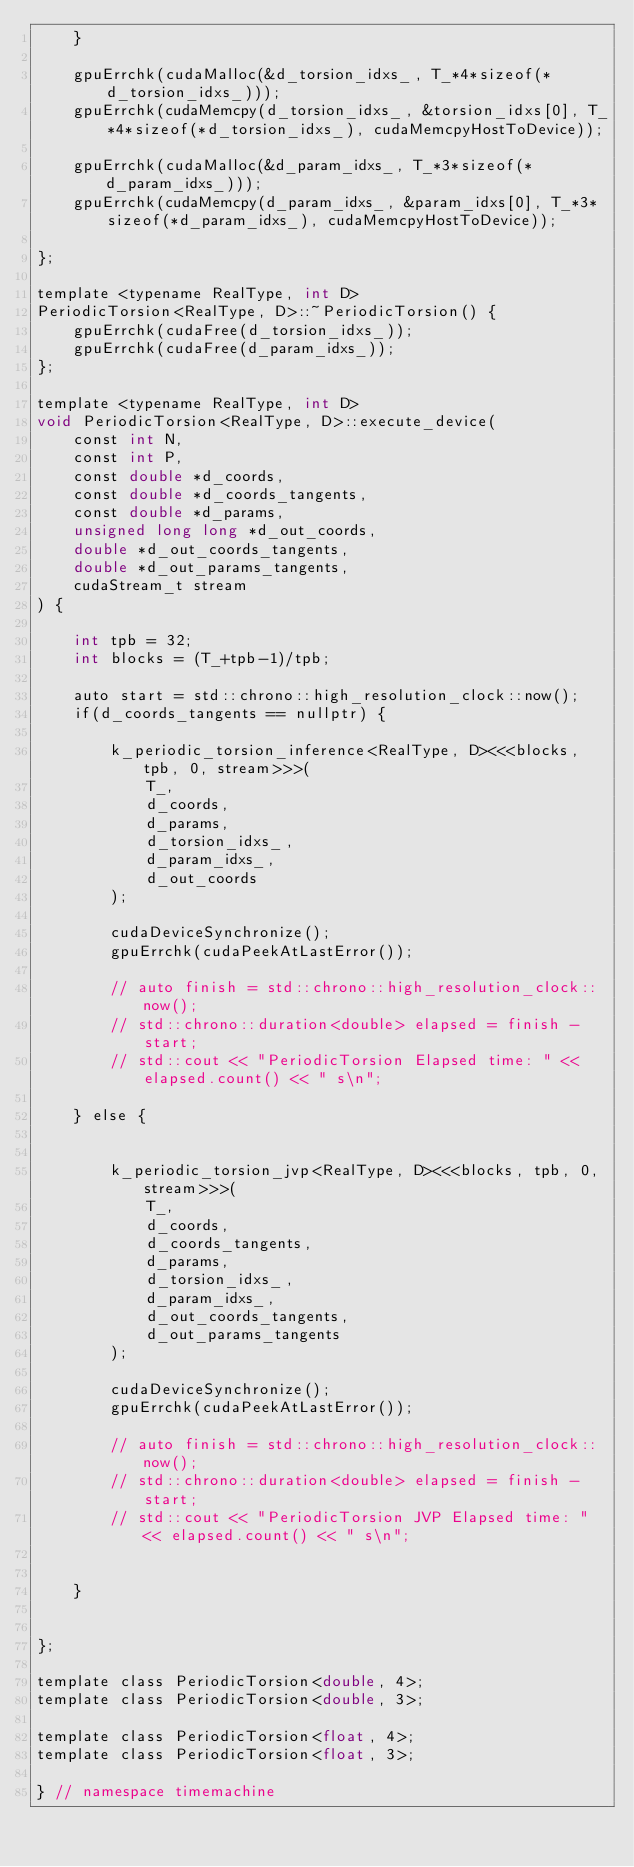<code> <loc_0><loc_0><loc_500><loc_500><_Cuda_>    }

    gpuErrchk(cudaMalloc(&d_torsion_idxs_, T_*4*sizeof(*d_torsion_idxs_)));
    gpuErrchk(cudaMemcpy(d_torsion_idxs_, &torsion_idxs[0], T_*4*sizeof(*d_torsion_idxs_), cudaMemcpyHostToDevice));

    gpuErrchk(cudaMalloc(&d_param_idxs_, T_*3*sizeof(*d_param_idxs_)));
    gpuErrchk(cudaMemcpy(d_param_idxs_, &param_idxs[0], T_*3*sizeof(*d_param_idxs_), cudaMemcpyHostToDevice));

};

template <typename RealType, int D>
PeriodicTorsion<RealType, D>::~PeriodicTorsion() {
    gpuErrchk(cudaFree(d_torsion_idxs_));
    gpuErrchk(cudaFree(d_param_idxs_));
};

template <typename RealType, int D>
void PeriodicTorsion<RealType, D>::execute_device(
    const int N,
    const int P,
    const double *d_coords,
    const double *d_coords_tangents,
    const double *d_params,
    unsigned long long *d_out_coords,
    double *d_out_coords_tangents,
    double *d_out_params_tangents,
    cudaStream_t stream
) {

    int tpb = 32;
    int blocks = (T_+tpb-1)/tpb;

    auto start = std::chrono::high_resolution_clock::now();
    if(d_coords_tangents == nullptr) {

        k_periodic_torsion_inference<RealType, D><<<blocks, tpb, 0, stream>>>(
            T_,
            d_coords,
            d_params,
            d_torsion_idxs_,
            d_param_idxs_,
            d_out_coords
        );

        cudaDeviceSynchronize();
        gpuErrchk(cudaPeekAtLastError());

        // auto finish = std::chrono::high_resolution_clock::now();
        // std::chrono::duration<double> elapsed = finish - start;
        // std::cout << "PeriodicTorsion Elapsed time: " << elapsed.count() << " s\n";

    } else {


        k_periodic_torsion_jvp<RealType, D><<<blocks, tpb, 0, stream>>>(
            T_,
            d_coords,
            d_coords_tangents,
            d_params,
            d_torsion_idxs_,
            d_param_idxs_,
            d_out_coords_tangents,
            d_out_params_tangents
        );

        cudaDeviceSynchronize();
        gpuErrchk(cudaPeekAtLastError());

        // auto finish = std::chrono::high_resolution_clock::now();
        // std::chrono::duration<double> elapsed = finish - start;
        // std::cout << "PeriodicTorsion JVP Elapsed time: " << elapsed.count() << " s\n";


    }


};

template class PeriodicTorsion<double, 4>;
template class PeriodicTorsion<double, 3>;

template class PeriodicTorsion<float, 4>;
template class PeriodicTorsion<float, 3>;

} // namespace timemachine</code> 